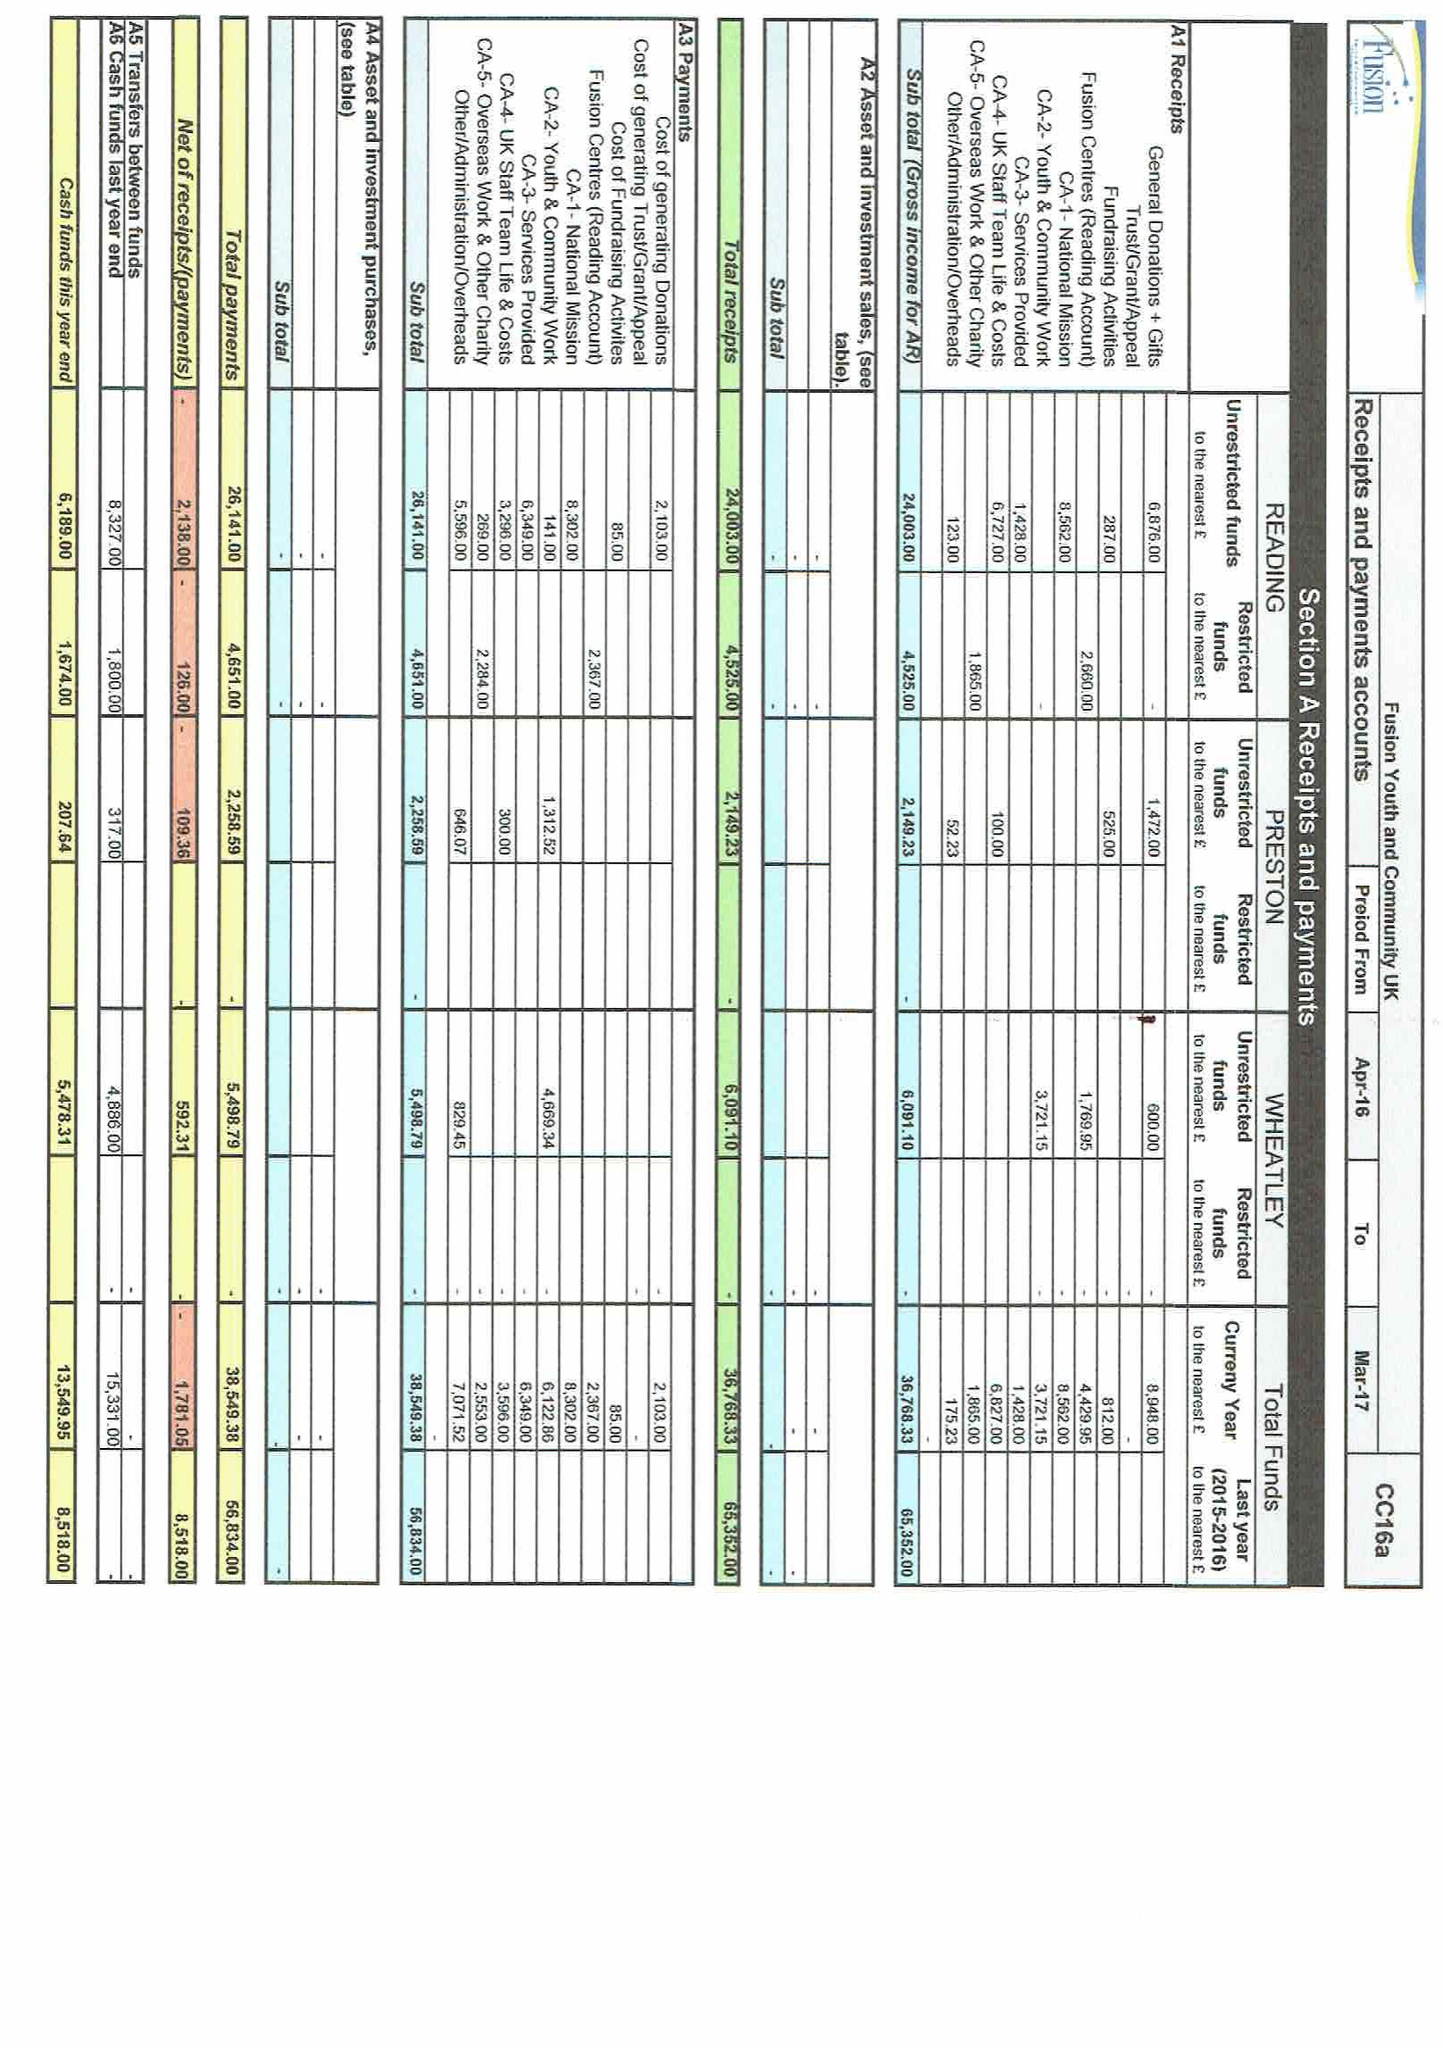What is the value for the address__street_line?
Answer the question using a single word or phrase. None 